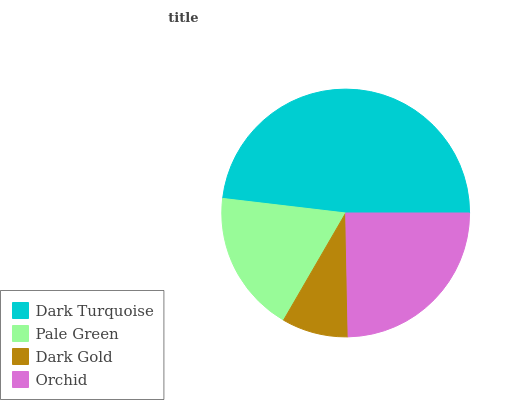Is Dark Gold the minimum?
Answer yes or no. Yes. Is Dark Turquoise the maximum?
Answer yes or no. Yes. Is Pale Green the minimum?
Answer yes or no. No. Is Pale Green the maximum?
Answer yes or no. No. Is Dark Turquoise greater than Pale Green?
Answer yes or no. Yes. Is Pale Green less than Dark Turquoise?
Answer yes or no. Yes. Is Pale Green greater than Dark Turquoise?
Answer yes or no. No. Is Dark Turquoise less than Pale Green?
Answer yes or no. No. Is Orchid the high median?
Answer yes or no. Yes. Is Pale Green the low median?
Answer yes or no. Yes. Is Dark Gold the high median?
Answer yes or no. No. Is Dark Gold the low median?
Answer yes or no. No. 